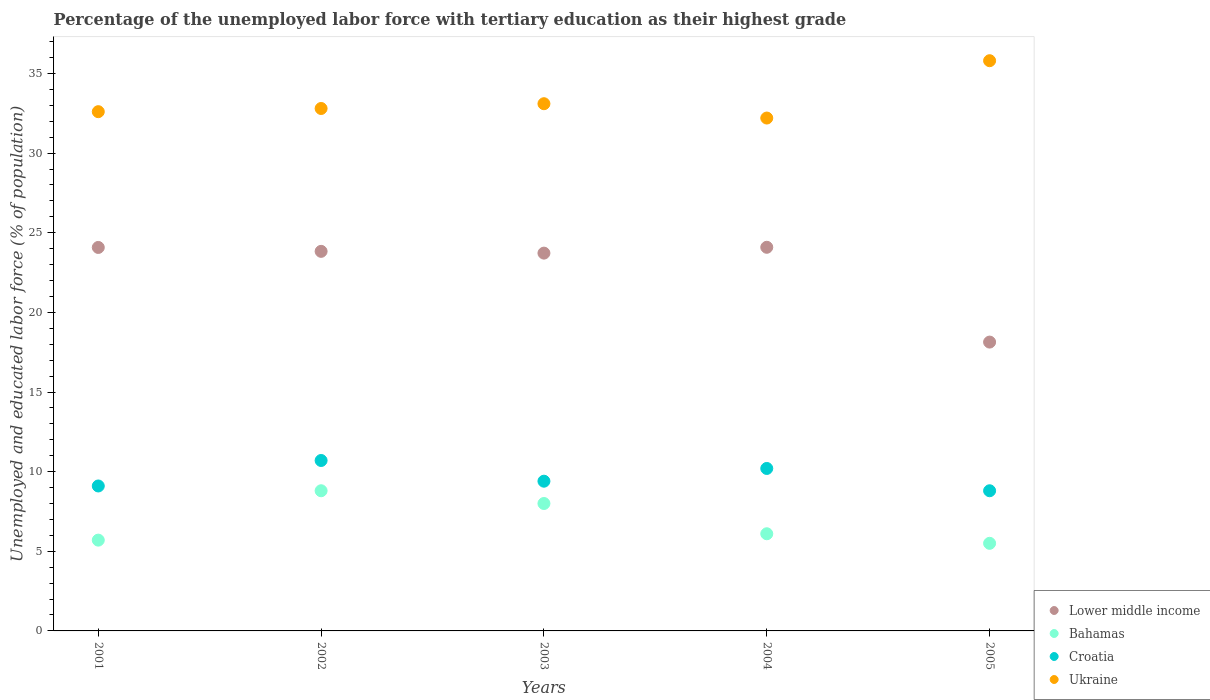What is the percentage of the unemployed labor force with tertiary education in Croatia in 2002?
Give a very brief answer. 10.7. Across all years, what is the maximum percentage of the unemployed labor force with tertiary education in Bahamas?
Provide a short and direct response. 8.8. Across all years, what is the minimum percentage of the unemployed labor force with tertiary education in Croatia?
Provide a short and direct response. 8.8. In which year was the percentage of the unemployed labor force with tertiary education in Bahamas maximum?
Offer a very short reply. 2002. What is the total percentage of the unemployed labor force with tertiary education in Lower middle income in the graph?
Your response must be concise. 113.84. What is the difference between the percentage of the unemployed labor force with tertiary education in Lower middle income in 2002 and that in 2005?
Your answer should be compact. 5.7. What is the difference between the percentage of the unemployed labor force with tertiary education in Ukraine in 2004 and the percentage of the unemployed labor force with tertiary education in Croatia in 2005?
Offer a terse response. 23.4. What is the average percentage of the unemployed labor force with tertiary education in Ukraine per year?
Provide a succinct answer. 33.3. In the year 2004, what is the difference between the percentage of the unemployed labor force with tertiary education in Bahamas and percentage of the unemployed labor force with tertiary education in Ukraine?
Keep it short and to the point. -26.1. What is the ratio of the percentage of the unemployed labor force with tertiary education in Ukraine in 2001 to that in 2003?
Offer a terse response. 0.98. Is the difference between the percentage of the unemployed labor force with tertiary education in Bahamas in 2001 and 2003 greater than the difference between the percentage of the unemployed labor force with tertiary education in Ukraine in 2001 and 2003?
Keep it short and to the point. No. What is the difference between the highest and the second highest percentage of the unemployed labor force with tertiary education in Ukraine?
Your answer should be very brief. 2.7. What is the difference between the highest and the lowest percentage of the unemployed labor force with tertiary education in Bahamas?
Your response must be concise. 3.3. In how many years, is the percentage of the unemployed labor force with tertiary education in Croatia greater than the average percentage of the unemployed labor force with tertiary education in Croatia taken over all years?
Offer a terse response. 2. Is the sum of the percentage of the unemployed labor force with tertiary education in Bahamas in 2003 and 2004 greater than the maximum percentage of the unemployed labor force with tertiary education in Croatia across all years?
Your answer should be very brief. Yes. Is it the case that in every year, the sum of the percentage of the unemployed labor force with tertiary education in Bahamas and percentage of the unemployed labor force with tertiary education in Croatia  is greater than the sum of percentage of the unemployed labor force with tertiary education in Ukraine and percentage of the unemployed labor force with tertiary education in Lower middle income?
Your response must be concise. No. Is it the case that in every year, the sum of the percentage of the unemployed labor force with tertiary education in Ukraine and percentage of the unemployed labor force with tertiary education in Bahamas  is greater than the percentage of the unemployed labor force with tertiary education in Lower middle income?
Your answer should be very brief. Yes. Does the percentage of the unemployed labor force with tertiary education in Ukraine monotonically increase over the years?
Give a very brief answer. No. How many dotlines are there?
Make the answer very short. 4. Are the values on the major ticks of Y-axis written in scientific E-notation?
Your response must be concise. No. Does the graph contain any zero values?
Your response must be concise. No. Does the graph contain grids?
Make the answer very short. No. Where does the legend appear in the graph?
Your answer should be very brief. Bottom right. What is the title of the graph?
Give a very brief answer. Percentage of the unemployed labor force with tertiary education as their highest grade. What is the label or title of the X-axis?
Offer a very short reply. Years. What is the label or title of the Y-axis?
Provide a short and direct response. Unemployed and educated labor force (% of population). What is the Unemployed and educated labor force (% of population) of Lower middle income in 2001?
Your response must be concise. 24.08. What is the Unemployed and educated labor force (% of population) in Bahamas in 2001?
Make the answer very short. 5.7. What is the Unemployed and educated labor force (% of population) in Croatia in 2001?
Provide a short and direct response. 9.1. What is the Unemployed and educated labor force (% of population) of Ukraine in 2001?
Provide a short and direct response. 32.6. What is the Unemployed and educated labor force (% of population) in Lower middle income in 2002?
Your answer should be compact. 23.83. What is the Unemployed and educated labor force (% of population) of Bahamas in 2002?
Give a very brief answer. 8.8. What is the Unemployed and educated labor force (% of population) of Croatia in 2002?
Make the answer very short. 10.7. What is the Unemployed and educated labor force (% of population) of Ukraine in 2002?
Offer a terse response. 32.8. What is the Unemployed and educated labor force (% of population) of Lower middle income in 2003?
Ensure brevity in your answer.  23.72. What is the Unemployed and educated labor force (% of population) in Croatia in 2003?
Ensure brevity in your answer.  9.4. What is the Unemployed and educated labor force (% of population) in Ukraine in 2003?
Offer a terse response. 33.1. What is the Unemployed and educated labor force (% of population) of Lower middle income in 2004?
Provide a short and direct response. 24.09. What is the Unemployed and educated labor force (% of population) of Bahamas in 2004?
Keep it short and to the point. 6.1. What is the Unemployed and educated labor force (% of population) in Croatia in 2004?
Provide a succinct answer. 10.2. What is the Unemployed and educated labor force (% of population) in Ukraine in 2004?
Offer a terse response. 32.2. What is the Unemployed and educated labor force (% of population) of Lower middle income in 2005?
Offer a very short reply. 18.13. What is the Unemployed and educated labor force (% of population) in Bahamas in 2005?
Provide a succinct answer. 5.5. What is the Unemployed and educated labor force (% of population) in Croatia in 2005?
Ensure brevity in your answer.  8.8. What is the Unemployed and educated labor force (% of population) in Ukraine in 2005?
Offer a terse response. 35.8. Across all years, what is the maximum Unemployed and educated labor force (% of population) in Lower middle income?
Ensure brevity in your answer.  24.09. Across all years, what is the maximum Unemployed and educated labor force (% of population) of Bahamas?
Ensure brevity in your answer.  8.8. Across all years, what is the maximum Unemployed and educated labor force (% of population) in Croatia?
Ensure brevity in your answer.  10.7. Across all years, what is the maximum Unemployed and educated labor force (% of population) of Ukraine?
Your response must be concise. 35.8. Across all years, what is the minimum Unemployed and educated labor force (% of population) of Lower middle income?
Make the answer very short. 18.13. Across all years, what is the minimum Unemployed and educated labor force (% of population) of Bahamas?
Offer a very short reply. 5.5. Across all years, what is the minimum Unemployed and educated labor force (% of population) of Croatia?
Give a very brief answer. 8.8. Across all years, what is the minimum Unemployed and educated labor force (% of population) in Ukraine?
Give a very brief answer. 32.2. What is the total Unemployed and educated labor force (% of population) of Lower middle income in the graph?
Ensure brevity in your answer.  113.84. What is the total Unemployed and educated labor force (% of population) of Bahamas in the graph?
Your answer should be compact. 34.1. What is the total Unemployed and educated labor force (% of population) in Croatia in the graph?
Keep it short and to the point. 48.2. What is the total Unemployed and educated labor force (% of population) of Ukraine in the graph?
Ensure brevity in your answer.  166.5. What is the difference between the Unemployed and educated labor force (% of population) in Lower middle income in 2001 and that in 2002?
Make the answer very short. 0.25. What is the difference between the Unemployed and educated labor force (% of population) in Bahamas in 2001 and that in 2002?
Your response must be concise. -3.1. What is the difference between the Unemployed and educated labor force (% of population) in Ukraine in 2001 and that in 2002?
Offer a terse response. -0.2. What is the difference between the Unemployed and educated labor force (% of population) in Lower middle income in 2001 and that in 2003?
Your answer should be very brief. 0.36. What is the difference between the Unemployed and educated labor force (% of population) in Bahamas in 2001 and that in 2003?
Offer a very short reply. -2.3. What is the difference between the Unemployed and educated labor force (% of population) in Ukraine in 2001 and that in 2003?
Your answer should be very brief. -0.5. What is the difference between the Unemployed and educated labor force (% of population) of Lower middle income in 2001 and that in 2004?
Your answer should be compact. -0.01. What is the difference between the Unemployed and educated labor force (% of population) of Croatia in 2001 and that in 2004?
Give a very brief answer. -1.1. What is the difference between the Unemployed and educated labor force (% of population) in Ukraine in 2001 and that in 2004?
Provide a short and direct response. 0.4. What is the difference between the Unemployed and educated labor force (% of population) in Lower middle income in 2001 and that in 2005?
Keep it short and to the point. 5.94. What is the difference between the Unemployed and educated labor force (% of population) of Lower middle income in 2002 and that in 2003?
Offer a terse response. 0.11. What is the difference between the Unemployed and educated labor force (% of population) in Bahamas in 2002 and that in 2003?
Give a very brief answer. 0.8. What is the difference between the Unemployed and educated labor force (% of population) in Ukraine in 2002 and that in 2003?
Give a very brief answer. -0.3. What is the difference between the Unemployed and educated labor force (% of population) of Lower middle income in 2002 and that in 2004?
Your answer should be compact. -0.26. What is the difference between the Unemployed and educated labor force (% of population) in Ukraine in 2002 and that in 2004?
Ensure brevity in your answer.  0.6. What is the difference between the Unemployed and educated labor force (% of population) of Lower middle income in 2002 and that in 2005?
Make the answer very short. 5.7. What is the difference between the Unemployed and educated labor force (% of population) of Lower middle income in 2003 and that in 2004?
Your answer should be compact. -0.37. What is the difference between the Unemployed and educated labor force (% of population) in Bahamas in 2003 and that in 2004?
Your answer should be compact. 1.9. What is the difference between the Unemployed and educated labor force (% of population) of Croatia in 2003 and that in 2004?
Make the answer very short. -0.8. What is the difference between the Unemployed and educated labor force (% of population) in Ukraine in 2003 and that in 2004?
Your answer should be very brief. 0.9. What is the difference between the Unemployed and educated labor force (% of population) in Lower middle income in 2003 and that in 2005?
Keep it short and to the point. 5.59. What is the difference between the Unemployed and educated labor force (% of population) in Bahamas in 2003 and that in 2005?
Offer a terse response. 2.5. What is the difference between the Unemployed and educated labor force (% of population) in Croatia in 2003 and that in 2005?
Ensure brevity in your answer.  0.6. What is the difference between the Unemployed and educated labor force (% of population) of Ukraine in 2003 and that in 2005?
Your response must be concise. -2.7. What is the difference between the Unemployed and educated labor force (% of population) in Lower middle income in 2004 and that in 2005?
Make the answer very short. 5.95. What is the difference between the Unemployed and educated labor force (% of population) of Bahamas in 2004 and that in 2005?
Keep it short and to the point. 0.6. What is the difference between the Unemployed and educated labor force (% of population) of Croatia in 2004 and that in 2005?
Keep it short and to the point. 1.4. What is the difference between the Unemployed and educated labor force (% of population) in Lower middle income in 2001 and the Unemployed and educated labor force (% of population) in Bahamas in 2002?
Offer a terse response. 15.28. What is the difference between the Unemployed and educated labor force (% of population) in Lower middle income in 2001 and the Unemployed and educated labor force (% of population) in Croatia in 2002?
Make the answer very short. 13.38. What is the difference between the Unemployed and educated labor force (% of population) of Lower middle income in 2001 and the Unemployed and educated labor force (% of population) of Ukraine in 2002?
Offer a terse response. -8.72. What is the difference between the Unemployed and educated labor force (% of population) of Bahamas in 2001 and the Unemployed and educated labor force (% of population) of Ukraine in 2002?
Offer a very short reply. -27.1. What is the difference between the Unemployed and educated labor force (% of population) of Croatia in 2001 and the Unemployed and educated labor force (% of population) of Ukraine in 2002?
Give a very brief answer. -23.7. What is the difference between the Unemployed and educated labor force (% of population) of Lower middle income in 2001 and the Unemployed and educated labor force (% of population) of Bahamas in 2003?
Offer a terse response. 16.08. What is the difference between the Unemployed and educated labor force (% of population) of Lower middle income in 2001 and the Unemployed and educated labor force (% of population) of Croatia in 2003?
Offer a very short reply. 14.68. What is the difference between the Unemployed and educated labor force (% of population) in Lower middle income in 2001 and the Unemployed and educated labor force (% of population) in Ukraine in 2003?
Your answer should be very brief. -9.02. What is the difference between the Unemployed and educated labor force (% of population) of Bahamas in 2001 and the Unemployed and educated labor force (% of population) of Croatia in 2003?
Ensure brevity in your answer.  -3.7. What is the difference between the Unemployed and educated labor force (% of population) of Bahamas in 2001 and the Unemployed and educated labor force (% of population) of Ukraine in 2003?
Offer a terse response. -27.4. What is the difference between the Unemployed and educated labor force (% of population) in Croatia in 2001 and the Unemployed and educated labor force (% of population) in Ukraine in 2003?
Your answer should be compact. -24. What is the difference between the Unemployed and educated labor force (% of population) in Lower middle income in 2001 and the Unemployed and educated labor force (% of population) in Bahamas in 2004?
Your answer should be compact. 17.98. What is the difference between the Unemployed and educated labor force (% of population) in Lower middle income in 2001 and the Unemployed and educated labor force (% of population) in Croatia in 2004?
Offer a terse response. 13.88. What is the difference between the Unemployed and educated labor force (% of population) of Lower middle income in 2001 and the Unemployed and educated labor force (% of population) of Ukraine in 2004?
Make the answer very short. -8.12. What is the difference between the Unemployed and educated labor force (% of population) in Bahamas in 2001 and the Unemployed and educated labor force (% of population) in Croatia in 2004?
Make the answer very short. -4.5. What is the difference between the Unemployed and educated labor force (% of population) of Bahamas in 2001 and the Unemployed and educated labor force (% of population) of Ukraine in 2004?
Ensure brevity in your answer.  -26.5. What is the difference between the Unemployed and educated labor force (% of population) in Croatia in 2001 and the Unemployed and educated labor force (% of population) in Ukraine in 2004?
Your answer should be compact. -23.1. What is the difference between the Unemployed and educated labor force (% of population) of Lower middle income in 2001 and the Unemployed and educated labor force (% of population) of Bahamas in 2005?
Your answer should be compact. 18.58. What is the difference between the Unemployed and educated labor force (% of population) in Lower middle income in 2001 and the Unemployed and educated labor force (% of population) in Croatia in 2005?
Your answer should be very brief. 15.28. What is the difference between the Unemployed and educated labor force (% of population) in Lower middle income in 2001 and the Unemployed and educated labor force (% of population) in Ukraine in 2005?
Offer a terse response. -11.72. What is the difference between the Unemployed and educated labor force (% of population) of Bahamas in 2001 and the Unemployed and educated labor force (% of population) of Ukraine in 2005?
Provide a short and direct response. -30.1. What is the difference between the Unemployed and educated labor force (% of population) of Croatia in 2001 and the Unemployed and educated labor force (% of population) of Ukraine in 2005?
Offer a very short reply. -26.7. What is the difference between the Unemployed and educated labor force (% of population) of Lower middle income in 2002 and the Unemployed and educated labor force (% of population) of Bahamas in 2003?
Your response must be concise. 15.83. What is the difference between the Unemployed and educated labor force (% of population) in Lower middle income in 2002 and the Unemployed and educated labor force (% of population) in Croatia in 2003?
Provide a succinct answer. 14.43. What is the difference between the Unemployed and educated labor force (% of population) of Lower middle income in 2002 and the Unemployed and educated labor force (% of population) of Ukraine in 2003?
Offer a very short reply. -9.27. What is the difference between the Unemployed and educated labor force (% of population) of Bahamas in 2002 and the Unemployed and educated labor force (% of population) of Croatia in 2003?
Offer a very short reply. -0.6. What is the difference between the Unemployed and educated labor force (% of population) of Bahamas in 2002 and the Unemployed and educated labor force (% of population) of Ukraine in 2003?
Keep it short and to the point. -24.3. What is the difference between the Unemployed and educated labor force (% of population) of Croatia in 2002 and the Unemployed and educated labor force (% of population) of Ukraine in 2003?
Make the answer very short. -22.4. What is the difference between the Unemployed and educated labor force (% of population) of Lower middle income in 2002 and the Unemployed and educated labor force (% of population) of Bahamas in 2004?
Provide a short and direct response. 17.73. What is the difference between the Unemployed and educated labor force (% of population) in Lower middle income in 2002 and the Unemployed and educated labor force (% of population) in Croatia in 2004?
Offer a very short reply. 13.63. What is the difference between the Unemployed and educated labor force (% of population) in Lower middle income in 2002 and the Unemployed and educated labor force (% of population) in Ukraine in 2004?
Give a very brief answer. -8.37. What is the difference between the Unemployed and educated labor force (% of population) in Bahamas in 2002 and the Unemployed and educated labor force (% of population) in Croatia in 2004?
Your answer should be very brief. -1.4. What is the difference between the Unemployed and educated labor force (% of population) in Bahamas in 2002 and the Unemployed and educated labor force (% of population) in Ukraine in 2004?
Give a very brief answer. -23.4. What is the difference between the Unemployed and educated labor force (% of population) in Croatia in 2002 and the Unemployed and educated labor force (% of population) in Ukraine in 2004?
Make the answer very short. -21.5. What is the difference between the Unemployed and educated labor force (% of population) of Lower middle income in 2002 and the Unemployed and educated labor force (% of population) of Bahamas in 2005?
Your response must be concise. 18.33. What is the difference between the Unemployed and educated labor force (% of population) in Lower middle income in 2002 and the Unemployed and educated labor force (% of population) in Croatia in 2005?
Provide a succinct answer. 15.03. What is the difference between the Unemployed and educated labor force (% of population) in Lower middle income in 2002 and the Unemployed and educated labor force (% of population) in Ukraine in 2005?
Offer a very short reply. -11.97. What is the difference between the Unemployed and educated labor force (% of population) of Croatia in 2002 and the Unemployed and educated labor force (% of population) of Ukraine in 2005?
Your answer should be very brief. -25.1. What is the difference between the Unemployed and educated labor force (% of population) in Lower middle income in 2003 and the Unemployed and educated labor force (% of population) in Bahamas in 2004?
Ensure brevity in your answer.  17.62. What is the difference between the Unemployed and educated labor force (% of population) of Lower middle income in 2003 and the Unemployed and educated labor force (% of population) of Croatia in 2004?
Keep it short and to the point. 13.52. What is the difference between the Unemployed and educated labor force (% of population) of Lower middle income in 2003 and the Unemployed and educated labor force (% of population) of Ukraine in 2004?
Give a very brief answer. -8.48. What is the difference between the Unemployed and educated labor force (% of population) in Bahamas in 2003 and the Unemployed and educated labor force (% of population) in Croatia in 2004?
Offer a terse response. -2.2. What is the difference between the Unemployed and educated labor force (% of population) of Bahamas in 2003 and the Unemployed and educated labor force (% of population) of Ukraine in 2004?
Your response must be concise. -24.2. What is the difference between the Unemployed and educated labor force (% of population) of Croatia in 2003 and the Unemployed and educated labor force (% of population) of Ukraine in 2004?
Ensure brevity in your answer.  -22.8. What is the difference between the Unemployed and educated labor force (% of population) of Lower middle income in 2003 and the Unemployed and educated labor force (% of population) of Bahamas in 2005?
Ensure brevity in your answer.  18.22. What is the difference between the Unemployed and educated labor force (% of population) in Lower middle income in 2003 and the Unemployed and educated labor force (% of population) in Croatia in 2005?
Your answer should be compact. 14.92. What is the difference between the Unemployed and educated labor force (% of population) in Lower middle income in 2003 and the Unemployed and educated labor force (% of population) in Ukraine in 2005?
Keep it short and to the point. -12.08. What is the difference between the Unemployed and educated labor force (% of population) of Bahamas in 2003 and the Unemployed and educated labor force (% of population) of Croatia in 2005?
Your answer should be very brief. -0.8. What is the difference between the Unemployed and educated labor force (% of population) in Bahamas in 2003 and the Unemployed and educated labor force (% of population) in Ukraine in 2005?
Ensure brevity in your answer.  -27.8. What is the difference between the Unemployed and educated labor force (% of population) in Croatia in 2003 and the Unemployed and educated labor force (% of population) in Ukraine in 2005?
Provide a succinct answer. -26.4. What is the difference between the Unemployed and educated labor force (% of population) of Lower middle income in 2004 and the Unemployed and educated labor force (% of population) of Bahamas in 2005?
Provide a succinct answer. 18.59. What is the difference between the Unemployed and educated labor force (% of population) of Lower middle income in 2004 and the Unemployed and educated labor force (% of population) of Croatia in 2005?
Ensure brevity in your answer.  15.29. What is the difference between the Unemployed and educated labor force (% of population) of Lower middle income in 2004 and the Unemployed and educated labor force (% of population) of Ukraine in 2005?
Provide a short and direct response. -11.71. What is the difference between the Unemployed and educated labor force (% of population) of Bahamas in 2004 and the Unemployed and educated labor force (% of population) of Ukraine in 2005?
Offer a very short reply. -29.7. What is the difference between the Unemployed and educated labor force (% of population) in Croatia in 2004 and the Unemployed and educated labor force (% of population) in Ukraine in 2005?
Your response must be concise. -25.6. What is the average Unemployed and educated labor force (% of population) in Lower middle income per year?
Keep it short and to the point. 22.77. What is the average Unemployed and educated labor force (% of population) in Bahamas per year?
Keep it short and to the point. 6.82. What is the average Unemployed and educated labor force (% of population) of Croatia per year?
Your answer should be compact. 9.64. What is the average Unemployed and educated labor force (% of population) in Ukraine per year?
Offer a terse response. 33.3. In the year 2001, what is the difference between the Unemployed and educated labor force (% of population) of Lower middle income and Unemployed and educated labor force (% of population) of Bahamas?
Keep it short and to the point. 18.38. In the year 2001, what is the difference between the Unemployed and educated labor force (% of population) in Lower middle income and Unemployed and educated labor force (% of population) in Croatia?
Offer a terse response. 14.98. In the year 2001, what is the difference between the Unemployed and educated labor force (% of population) of Lower middle income and Unemployed and educated labor force (% of population) of Ukraine?
Provide a short and direct response. -8.52. In the year 2001, what is the difference between the Unemployed and educated labor force (% of population) of Bahamas and Unemployed and educated labor force (% of population) of Croatia?
Offer a very short reply. -3.4. In the year 2001, what is the difference between the Unemployed and educated labor force (% of population) of Bahamas and Unemployed and educated labor force (% of population) of Ukraine?
Offer a very short reply. -26.9. In the year 2001, what is the difference between the Unemployed and educated labor force (% of population) of Croatia and Unemployed and educated labor force (% of population) of Ukraine?
Make the answer very short. -23.5. In the year 2002, what is the difference between the Unemployed and educated labor force (% of population) in Lower middle income and Unemployed and educated labor force (% of population) in Bahamas?
Offer a very short reply. 15.03. In the year 2002, what is the difference between the Unemployed and educated labor force (% of population) in Lower middle income and Unemployed and educated labor force (% of population) in Croatia?
Your answer should be compact. 13.13. In the year 2002, what is the difference between the Unemployed and educated labor force (% of population) in Lower middle income and Unemployed and educated labor force (% of population) in Ukraine?
Your response must be concise. -8.97. In the year 2002, what is the difference between the Unemployed and educated labor force (% of population) of Croatia and Unemployed and educated labor force (% of population) of Ukraine?
Provide a short and direct response. -22.1. In the year 2003, what is the difference between the Unemployed and educated labor force (% of population) in Lower middle income and Unemployed and educated labor force (% of population) in Bahamas?
Offer a very short reply. 15.72. In the year 2003, what is the difference between the Unemployed and educated labor force (% of population) of Lower middle income and Unemployed and educated labor force (% of population) of Croatia?
Provide a short and direct response. 14.32. In the year 2003, what is the difference between the Unemployed and educated labor force (% of population) in Lower middle income and Unemployed and educated labor force (% of population) in Ukraine?
Your answer should be compact. -9.38. In the year 2003, what is the difference between the Unemployed and educated labor force (% of population) in Bahamas and Unemployed and educated labor force (% of population) in Croatia?
Offer a very short reply. -1.4. In the year 2003, what is the difference between the Unemployed and educated labor force (% of population) of Bahamas and Unemployed and educated labor force (% of population) of Ukraine?
Offer a very short reply. -25.1. In the year 2003, what is the difference between the Unemployed and educated labor force (% of population) in Croatia and Unemployed and educated labor force (% of population) in Ukraine?
Make the answer very short. -23.7. In the year 2004, what is the difference between the Unemployed and educated labor force (% of population) in Lower middle income and Unemployed and educated labor force (% of population) in Bahamas?
Offer a terse response. 17.99. In the year 2004, what is the difference between the Unemployed and educated labor force (% of population) of Lower middle income and Unemployed and educated labor force (% of population) of Croatia?
Offer a terse response. 13.89. In the year 2004, what is the difference between the Unemployed and educated labor force (% of population) in Lower middle income and Unemployed and educated labor force (% of population) in Ukraine?
Give a very brief answer. -8.11. In the year 2004, what is the difference between the Unemployed and educated labor force (% of population) in Bahamas and Unemployed and educated labor force (% of population) in Ukraine?
Make the answer very short. -26.1. In the year 2004, what is the difference between the Unemployed and educated labor force (% of population) in Croatia and Unemployed and educated labor force (% of population) in Ukraine?
Your answer should be very brief. -22. In the year 2005, what is the difference between the Unemployed and educated labor force (% of population) of Lower middle income and Unemployed and educated labor force (% of population) of Bahamas?
Provide a short and direct response. 12.63. In the year 2005, what is the difference between the Unemployed and educated labor force (% of population) of Lower middle income and Unemployed and educated labor force (% of population) of Croatia?
Ensure brevity in your answer.  9.33. In the year 2005, what is the difference between the Unemployed and educated labor force (% of population) in Lower middle income and Unemployed and educated labor force (% of population) in Ukraine?
Your answer should be compact. -17.67. In the year 2005, what is the difference between the Unemployed and educated labor force (% of population) of Bahamas and Unemployed and educated labor force (% of population) of Ukraine?
Give a very brief answer. -30.3. What is the ratio of the Unemployed and educated labor force (% of population) in Lower middle income in 2001 to that in 2002?
Ensure brevity in your answer.  1.01. What is the ratio of the Unemployed and educated labor force (% of population) in Bahamas in 2001 to that in 2002?
Make the answer very short. 0.65. What is the ratio of the Unemployed and educated labor force (% of population) in Croatia in 2001 to that in 2002?
Offer a terse response. 0.85. What is the ratio of the Unemployed and educated labor force (% of population) in Ukraine in 2001 to that in 2002?
Offer a very short reply. 0.99. What is the ratio of the Unemployed and educated labor force (% of population) of Bahamas in 2001 to that in 2003?
Offer a very short reply. 0.71. What is the ratio of the Unemployed and educated labor force (% of population) in Croatia in 2001 to that in 2003?
Your answer should be very brief. 0.97. What is the ratio of the Unemployed and educated labor force (% of population) in Ukraine in 2001 to that in 2003?
Offer a terse response. 0.98. What is the ratio of the Unemployed and educated labor force (% of population) of Lower middle income in 2001 to that in 2004?
Offer a very short reply. 1. What is the ratio of the Unemployed and educated labor force (% of population) of Bahamas in 2001 to that in 2004?
Your response must be concise. 0.93. What is the ratio of the Unemployed and educated labor force (% of population) in Croatia in 2001 to that in 2004?
Offer a very short reply. 0.89. What is the ratio of the Unemployed and educated labor force (% of population) of Ukraine in 2001 to that in 2004?
Make the answer very short. 1.01. What is the ratio of the Unemployed and educated labor force (% of population) of Lower middle income in 2001 to that in 2005?
Offer a very short reply. 1.33. What is the ratio of the Unemployed and educated labor force (% of population) in Bahamas in 2001 to that in 2005?
Provide a short and direct response. 1.04. What is the ratio of the Unemployed and educated labor force (% of population) of Croatia in 2001 to that in 2005?
Your answer should be compact. 1.03. What is the ratio of the Unemployed and educated labor force (% of population) in Ukraine in 2001 to that in 2005?
Give a very brief answer. 0.91. What is the ratio of the Unemployed and educated labor force (% of population) in Croatia in 2002 to that in 2003?
Make the answer very short. 1.14. What is the ratio of the Unemployed and educated labor force (% of population) of Ukraine in 2002 to that in 2003?
Offer a terse response. 0.99. What is the ratio of the Unemployed and educated labor force (% of population) in Lower middle income in 2002 to that in 2004?
Ensure brevity in your answer.  0.99. What is the ratio of the Unemployed and educated labor force (% of population) in Bahamas in 2002 to that in 2004?
Provide a succinct answer. 1.44. What is the ratio of the Unemployed and educated labor force (% of population) of Croatia in 2002 to that in 2004?
Give a very brief answer. 1.05. What is the ratio of the Unemployed and educated labor force (% of population) of Ukraine in 2002 to that in 2004?
Offer a very short reply. 1.02. What is the ratio of the Unemployed and educated labor force (% of population) in Lower middle income in 2002 to that in 2005?
Offer a terse response. 1.31. What is the ratio of the Unemployed and educated labor force (% of population) of Bahamas in 2002 to that in 2005?
Your response must be concise. 1.6. What is the ratio of the Unemployed and educated labor force (% of population) in Croatia in 2002 to that in 2005?
Make the answer very short. 1.22. What is the ratio of the Unemployed and educated labor force (% of population) in Ukraine in 2002 to that in 2005?
Ensure brevity in your answer.  0.92. What is the ratio of the Unemployed and educated labor force (% of population) of Bahamas in 2003 to that in 2004?
Offer a very short reply. 1.31. What is the ratio of the Unemployed and educated labor force (% of population) of Croatia in 2003 to that in 2004?
Make the answer very short. 0.92. What is the ratio of the Unemployed and educated labor force (% of population) in Ukraine in 2003 to that in 2004?
Offer a terse response. 1.03. What is the ratio of the Unemployed and educated labor force (% of population) of Lower middle income in 2003 to that in 2005?
Offer a terse response. 1.31. What is the ratio of the Unemployed and educated labor force (% of population) of Bahamas in 2003 to that in 2005?
Offer a very short reply. 1.45. What is the ratio of the Unemployed and educated labor force (% of population) in Croatia in 2003 to that in 2005?
Offer a very short reply. 1.07. What is the ratio of the Unemployed and educated labor force (% of population) in Ukraine in 2003 to that in 2005?
Offer a terse response. 0.92. What is the ratio of the Unemployed and educated labor force (% of population) of Lower middle income in 2004 to that in 2005?
Your response must be concise. 1.33. What is the ratio of the Unemployed and educated labor force (% of population) of Bahamas in 2004 to that in 2005?
Give a very brief answer. 1.11. What is the ratio of the Unemployed and educated labor force (% of population) of Croatia in 2004 to that in 2005?
Offer a terse response. 1.16. What is the ratio of the Unemployed and educated labor force (% of population) in Ukraine in 2004 to that in 2005?
Your answer should be compact. 0.9. What is the difference between the highest and the second highest Unemployed and educated labor force (% of population) of Lower middle income?
Offer a very short reply. 0.01. What is the difference between the highest and the second highest Unemployed and educated labor force (% of population) of Bahamas?
Offer a very short reply. 0.8. What is the difference between the highest and the lowest Unemployed and educated labor force (% of population) of Lower middle income?
Give a very brief answer. 5.95. What is the difference between the highest and the lowest Unemployed and educated labor force (% of population) in Bahamas?
Your response must be concise. 3.3. What is the difference between the highest and the lowest Unemployed and educated labor force (% of population) in Croatia?
Make the answer very short. 1.9. 